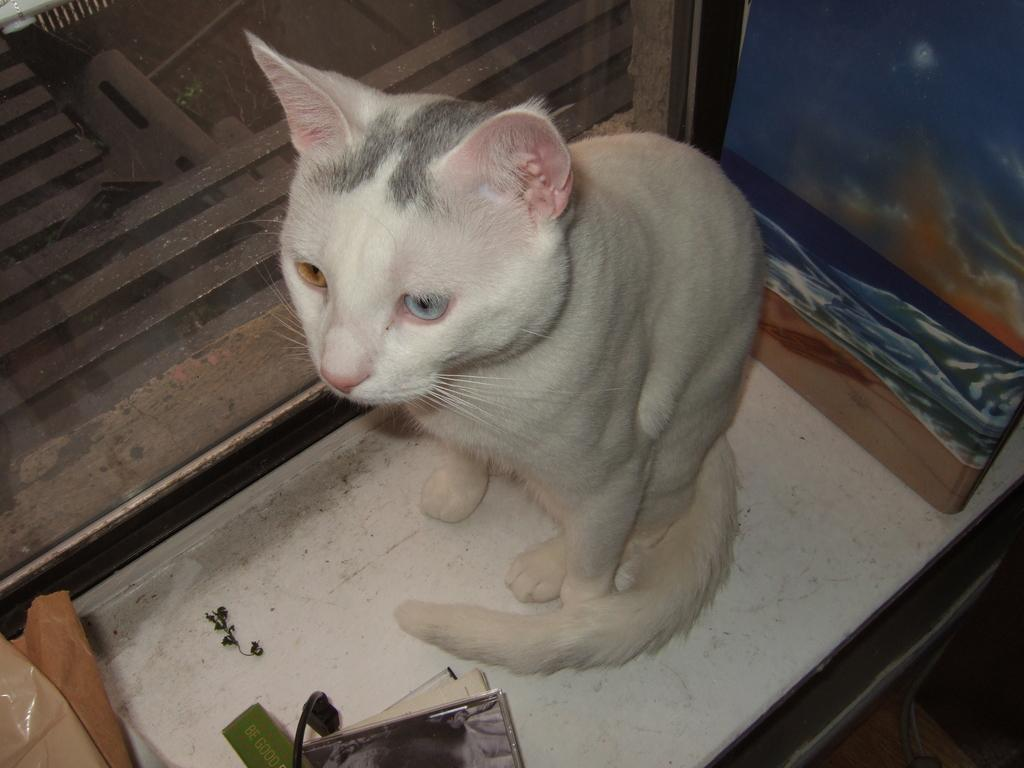What type of animal is in the image? There is a white-colored cat in the image. What is the cat doing in the image? The cat is sitting. Can you describe any other objects or elements in the image besides the cat? There are other unspecified stuffs in the image. What type of instrument is the cat playing in the image? There is no instrument present in the image, and the cat is not playing any instrument. 